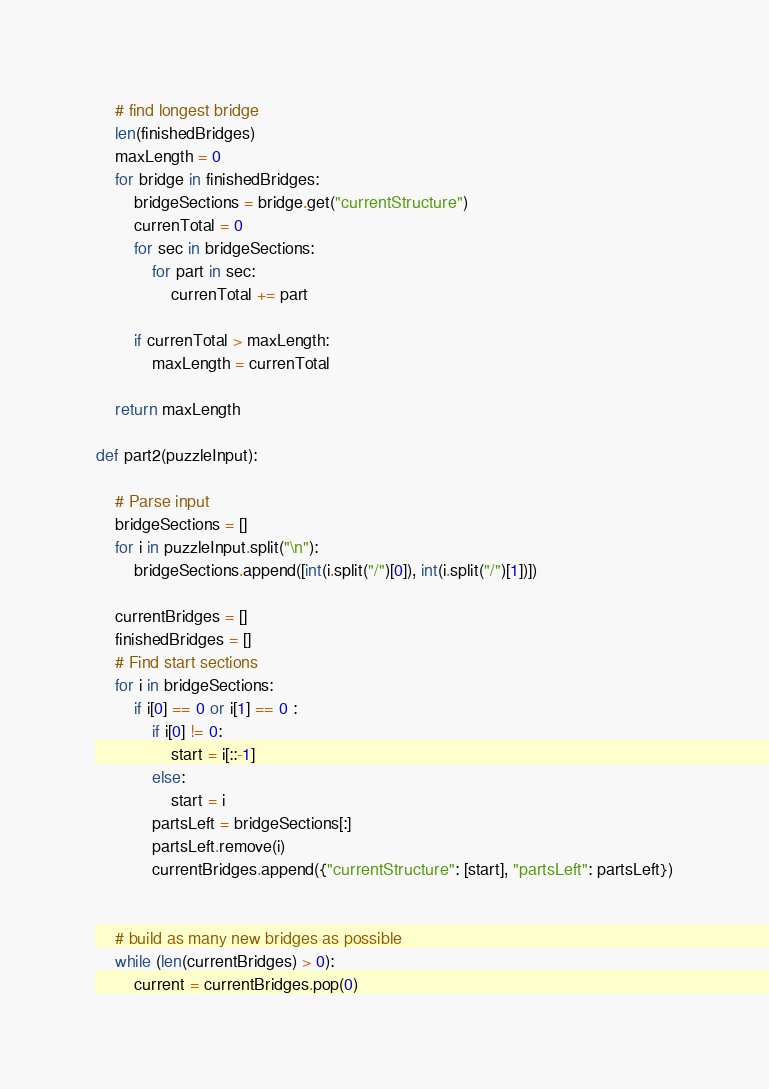<code> <loc_0><loc_0><loc_500><loc_500><_Python_>

    # find longest bridge
    len(finishedBridges)
    maxLength = 0
    for bridge in finishedBridges:
        bridgeSections = bridge.get("currentStructure")
        currenTotal = 0
        for sec in bridgeSections:
            for part in sec:
                currenTotal += part
                
        if currenTotal > maxLength:
            maxLength = currenTotal

    return maxLength

def part2(puzzleInput):

    # Parse input
    bridgeSections = []
    for i in puzzleInput.split("\n"):
        bridgeSections.append([int(i.split("/")[0]), int(i.split("/")[1])])

    currentBridges = []
    finishedBridges = []
    # Find start sections
    for i in bridgeSections:
        if i[0] == 0 or i[1] == 0 :
            if i[0] != 0:
                start = i[::-1]
            else:
                start = i
            partsLeft = bridgeSections[:] 
            partsLeft.remove(i)
            currentBridges.append({"currentStructure": [start], "partsLeft": partsLeft})


    # build as many new bridges as possible
    while (len(currentBridges) > 0):
        current = currentBridges.pop(0)</code> 